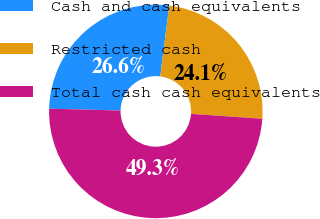<chart> <loc_0><loc_0><loc_500><loc_500><pie_chart><fcel>Cash and cash equivalents<fcel>Restricted cash<fcel>Total cash cash equivalents<nl><fcel>26.61%<fcel>24.09%<fcel>49.31%<nl></chart> 